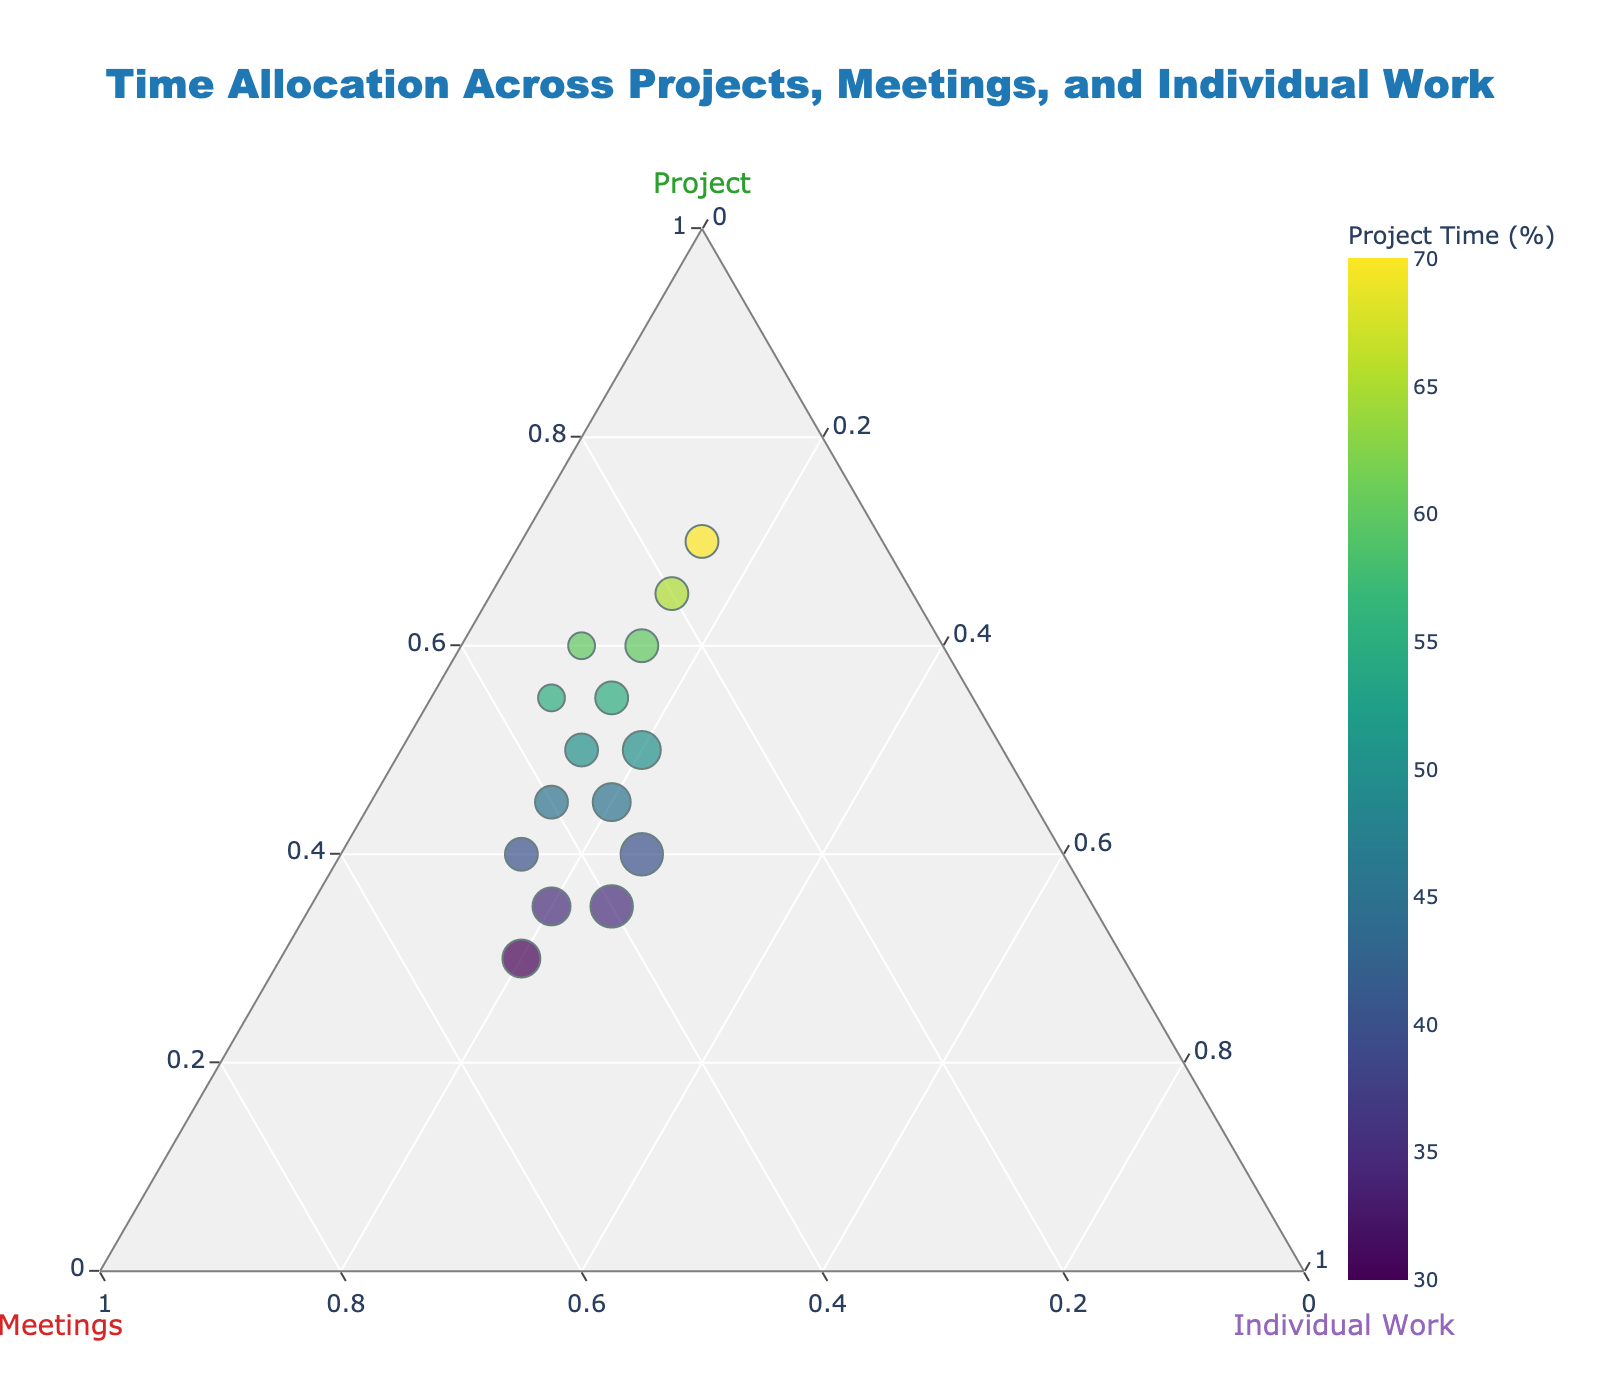How many data points are there in the figure? The figure shows a scatter plot where each point represents a row in the data table. By counting the points in the plot, you can see there are 15 data points.
Answer: 15 Which axis represents the percentage of time spent on individual work? In a ternary plot, there are three axes. The axis labeled with "Individual Work" represents the percentage of time spent on individual work.
Answer: c-axis What percentage range is used for the Project time in the color scale? By observing the color bar on the right side of the plot, you can see the percentage range for the Project time. The color bar indicates that the range is from 30% to 70%.
Answer: 30% to 70% Which data point has the largest size marker? The size of the marker represents the percentage of time spent on individual work. By looking at the largest marker, you can see that the data point with coordinates 40% (Projects), 35% (Meetings), and 25% (Individual Work) has the largest size.
Answer: 40%, 35%, 25% What is the title of the figure? The figure's title can be seen at the top center of the plot. It reads, "Time Allocation Across Projects, Meetings, and Individual Work".
Answer: Time Allocation Across Projects, Meetings, and Individual Work Which data point has the lowest percentage of time spent on meetings? To find the data point with the lowest percentage of meetings, observe the points near the bottom vertex of the ternary plot. The data point with coordinates 70% (Projects), 15% (Meetings), and 15% (Individual Work) represents the lowest meeting percentage.
Answer: 70%, 15%, 15% Compare the time allocation for individual work of the points with the highest and lowest Project time. What is the difference? The highest Project time is 70% with 15% Individual Work, the lowest Project time is 30% with 20% Individual Work. The difference is 20% - 15% = 5%.
Answer: 5% How does the size of markers generally compare to the color gradient? The size of the markers represents the individual work percentage while the color represents the project percentage. By observing the plot, one can see that higher percentages of individual work (larger markers) do not correspond with higher or lower color gradients. For example, larger markers appear at various points on the color gradient.
Answer: No clear relation Which color on the plot represents the highest amount of time spent on projects? The color bar indicates that the highest project time (70%) is represented by the darkest color on the Viridis scale.
Answer: Darkest color (near the end of the scale) Are there more data points with Project time percentages above or below 50%? Count the data points with Project percentages above and below 50%. There are 8 data points above 50% (55, 60, 50, 65, 55, 60, 70, 50) and 7 data points below 50% (40, 45, 35, 30, 40, 35, 45).
Answer: Above 50% (8) 